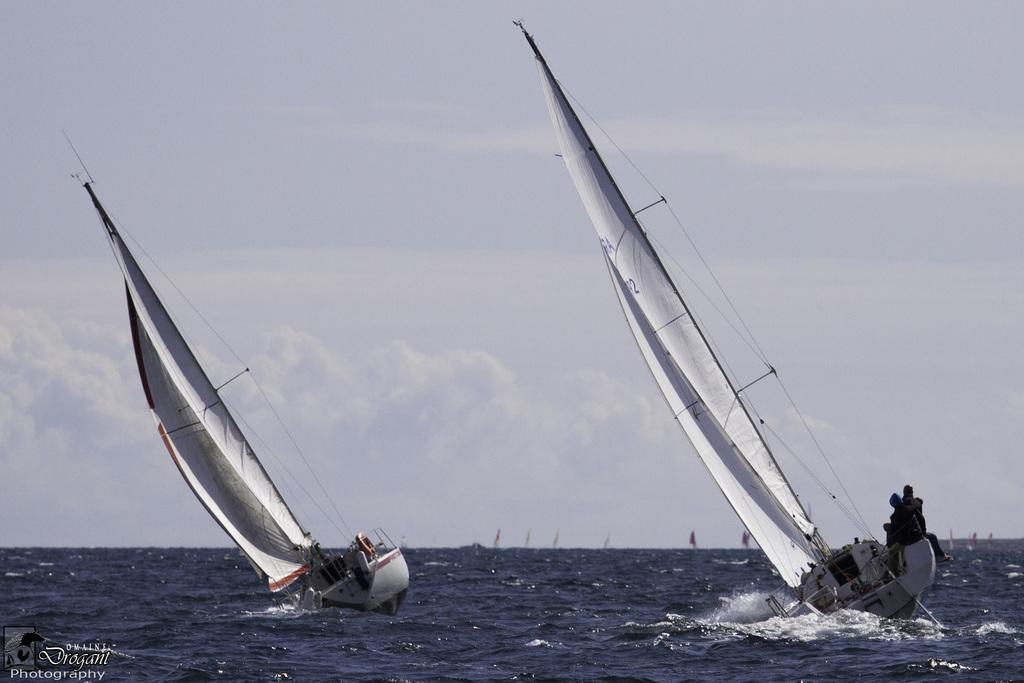What type of vehicles are in the image? There are boats in the image. Where are the boats located? The boats are on the water. Is there any text or marking in the image? Yes, there is a watermark in the bottom left corner of the image. What can be seen in the background of the image? The sky is visible in the background of the image. Where is the playground located in the image? There is no playground present in the image; it features boats on the water. What type of food is being used as a prop in the image? There is no food, such as a pickle, present in the image. 